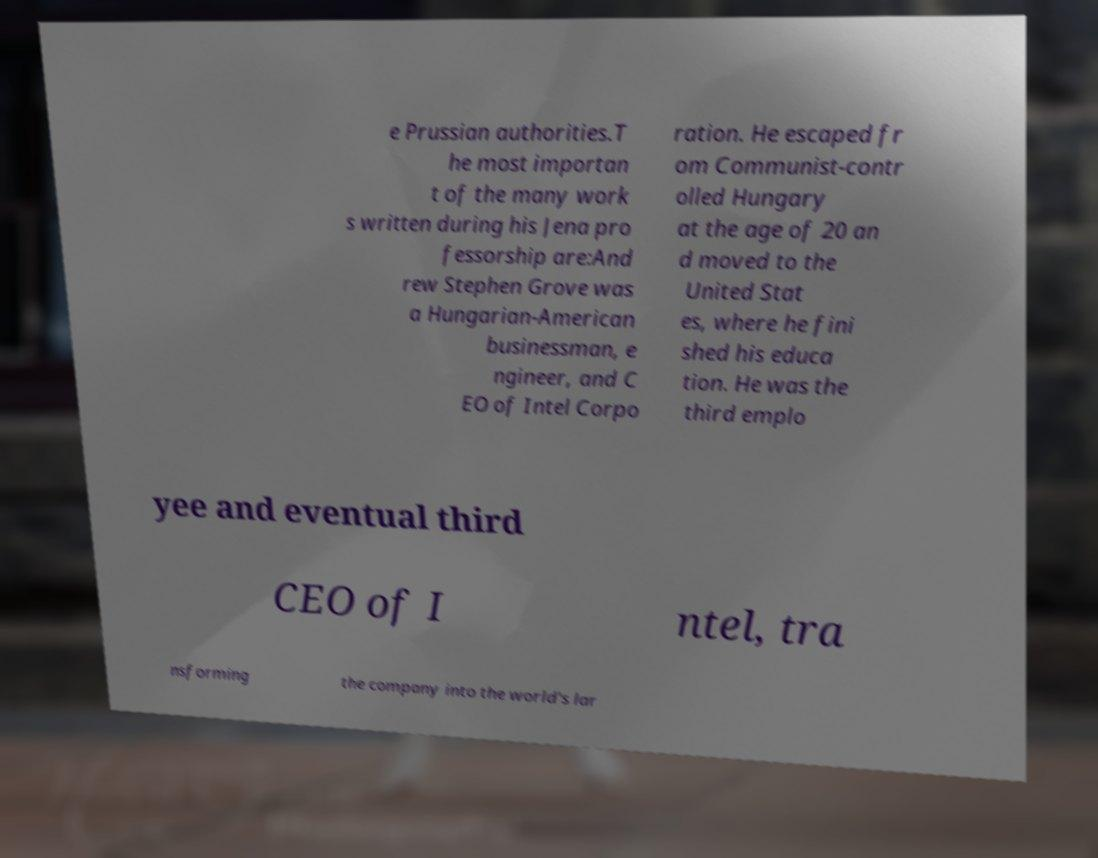There's text embedded in this image that I need extracted. Can you transcribe it verbatim? e Prussian authorities.T he most importan t of the many work s written during his Jena pro fessorship are:And rew Stephen Grove was a Hungarian-American businessman, e ngineer, and C EO of Intel Corpo ration. He escaped fr om Communist-contr olled Hungary at the age of 20 an d moved to the United Stat es, where he fini shed his educa tion. He was the third emplo yee and eventual third CEO of I ntel, tra nsforming the company into the world's lar 